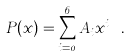<formula> <loc_0><loc_0><loc_500><loc_500>P ( x ) = \sum _ { i = 0 } ^ { 6 } A _ { i } x ^ { i } \ .</formula> 